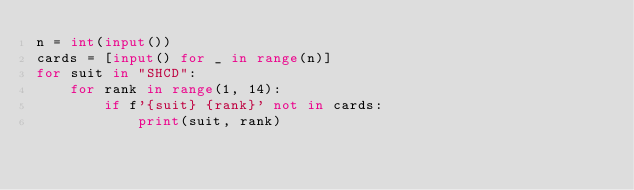Convert code to text. <code><loc_0><loc_0><loc_500><loc_500><_Python_>n = int(input())
cards = [input() for _ in range(n)]
for suit in "SHCD":
    for rank in range(1, 14):
        if f'{suit} {rank}' not in cards:
            print(suit, rank)
</code> 